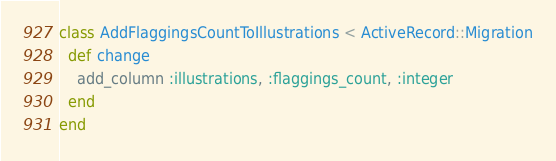Convert code to text. <code><loc_0><loc_0><loc_500><loc_500><_Ruby_>class AddFlaggingsCountToIllustrations < ActiveRecord::Migration
  def change
    add_column :illustrations, :flaggings_count, :integer
  end
end
</code> 